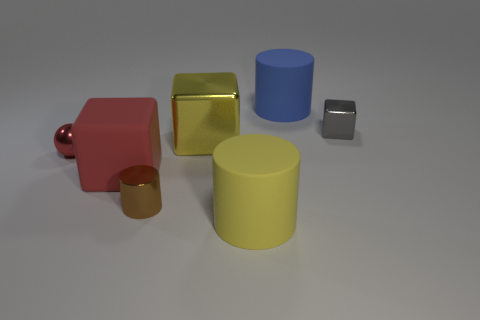Add 2 tiny cylinders. How many objects exist? 9 Subtract all cylinders. How many objects are left? 4 Subtract all tiny gray metal spheres. Subtract all yellow metal objects. How many objects are left? 6 Add 7 small gray metallic blocks. How many small gray metallic blocks are left? 8 Add 5 large yellow rubber cylinders. How many large yellow rubber cylinders exist? 6 Subtract 0 green spheres. How many objects are left? 7 